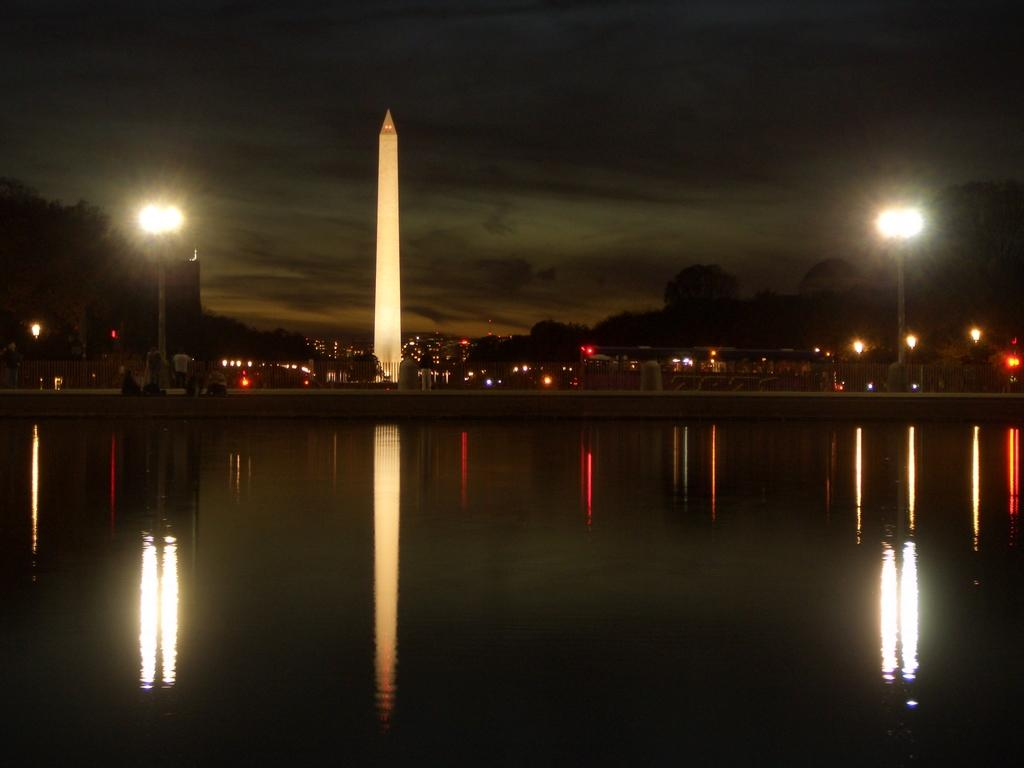Where was the image taken? The image was clicked outside. What can be seen in the middle of the image? There are lights, water, and buildings in the middle of the image. What is visible at the top of the image? The sky is visible at the top of the image. What type of skirt is being worn by the organization in the image? There is no skirt or organization present in the image. How many yards of fabric were used to create the yard in the image? There is no yard or fabric mentioned in the image. 